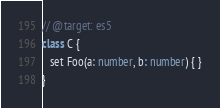<code> <loc_0><loc_0><loc_500><loc_500><_TypeScript_>// @target: es5
class C {
   set Foo(a: number, b: number) { }
}</code> 